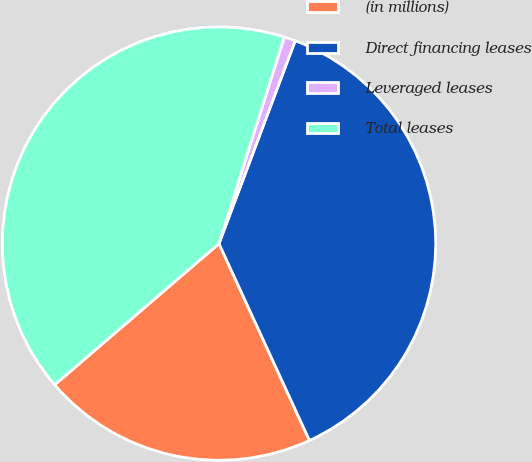<chart> <loc_0><loc_0><loc_500><loc_500><pie_chart><fcel>(in millions)<fcel>Direct financing leases<fcel>Leveraged leases<fcel>Total leases<nl><fcel>20.56%<fcel>37.43%<fcel>0.85%<fcel>41.17%<nl></chart> 